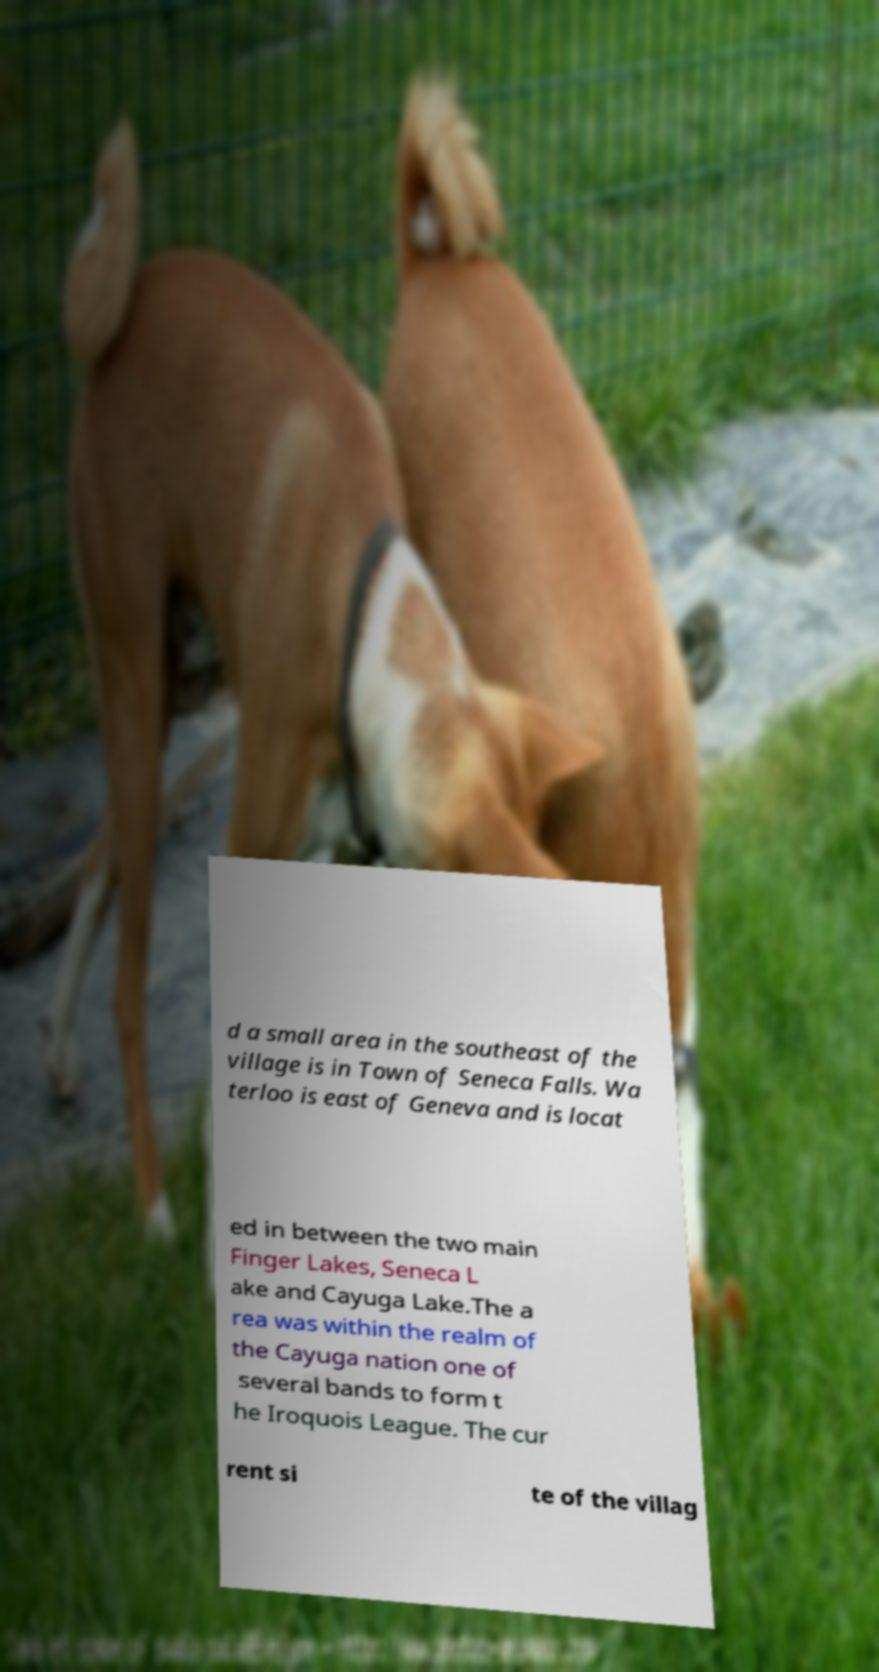Could you assist in decoding the text presented in this image and type it out clearly? d a small area in the southeast of the village is in Town of Seneca Falls. Wa terloo is east of Geneva and is locat ed in between the two main Finger Lakes, Seneca L ake and Cayuga Lake.The a rea was within the realm of the Cayuga nation one of several bands to form t he Iroquois League. The cur rent si te of the villag 